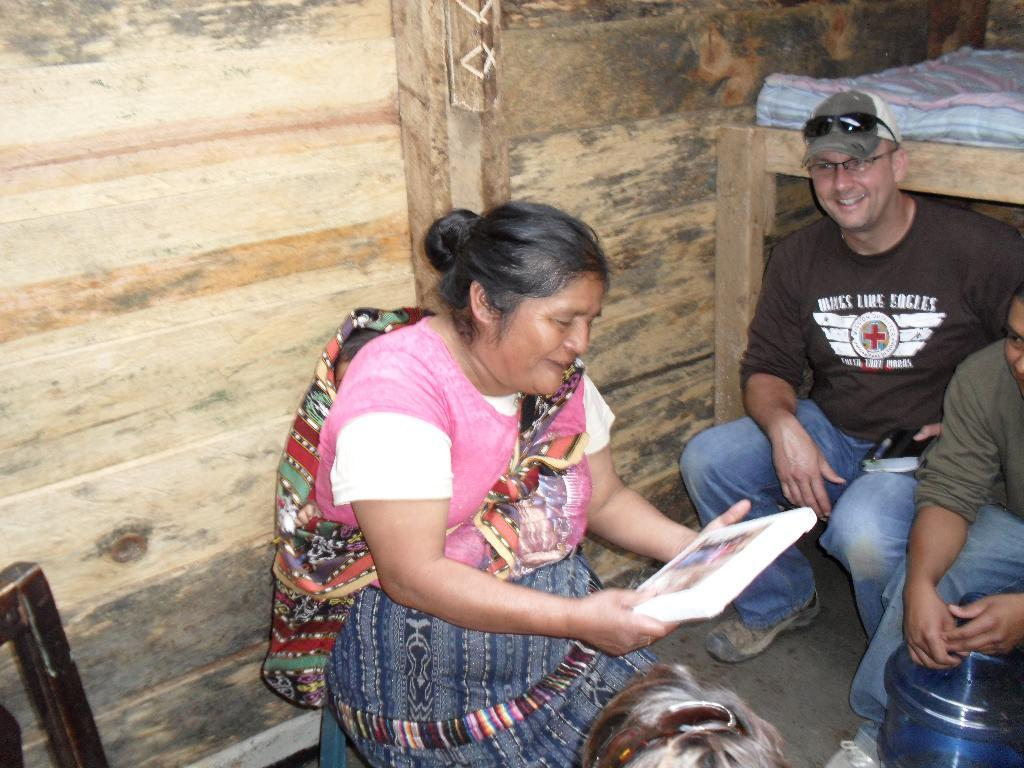What are the people in the image doing? The people in the image are sitting. What is the woman holding in her hand? A woman is holding something in her hand, but the specific object cannot be determined from the facts. What can be seen on the man's face in the image? The man is wearing glasses (specs) in the image. What type of wall is visible in the background of the image? There is a wooden wall in the background of the image. What type of scent can be detected in the image? There is no information about a scent in the image, so it cannot be determined. What type of approval is being given in the image? There is no indication of approval or disapproval in the image, so it cannot be determined. 